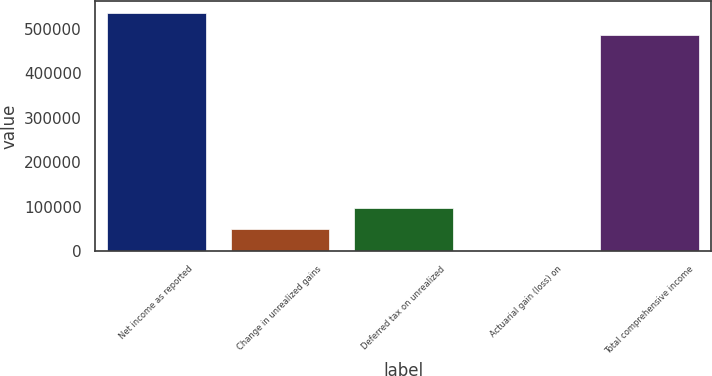Convert chart. <chart><loc_0><loc_0><loc_500><loc_500><bar_chart><fcel>Net income as reported<fcel>Change in unrealized gains<fcel>Deferred tax on unrealized<fcel>Actuarial gain (loss) on<fcel>Total comprehensive income<nl><fcel>535554<fcel>49161<fcel>98033<fcel>289<fcel>486682<nl></chart> 